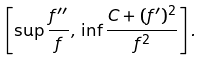<formula> <loc_0><loc_0><loc_500><loc_500>\left [ \sup \frac { f ^ { \prime \prime } } { f } , \, \inf \frac { C + ( f ^ { \prime } ) ^ { 2 } } { f ^ { 2 } } \right ] .</formula> 